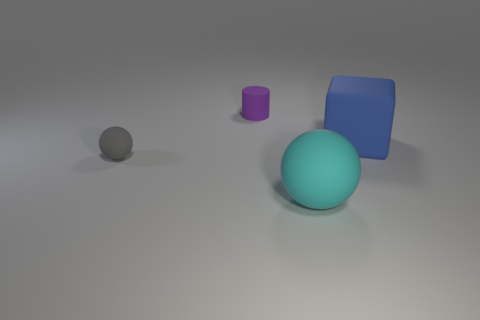What is the shape of the other object that is the same size as the gray rubber thing?
Provide a succinct answer. Cylinder. Are there any tiny balls of the same color as the large matte sphere?
Offer a very short reply. No. Is the number of large cyan spheres that are on the left side of the large sphere the same as the number of matte cylinders in front of the gray thing?
Offer a terse response. Yes. There is a large cyan rubber object; is it the same shape as the tiny thing in front of the large blue matte object?
Your response must be concise. Yes. There is a cyan rubber thing; are there any large objects right of it?
Your response must be concise. Yes. Does the cyan matte thing have the same size as the matte thing that is right of the cyan rubber thing?
Your answer should be very brief. Yes. There is a object that is right of the matte sphere that is in front of the tiny gray matte thing; what is its color?
Your answer should be very brief. Blue. Is the purple matte cylinder the same size as the gray matte sphere?
Keep it short and to the point. Yes. The matte thing that is right of the tiny purple matte object and behind the large ball is what color?
Ensure brevity in your answer.  Blue. The blue rubber block is what size?
Your answer should be very brief. Large. 